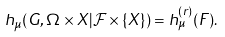Convert formula to latex. <formula><loc_0><loc_0><loc_500><loc_500>h _ { \mu } ( G , \Omega \times X | \mathcal { F } \times \{ X \} ) = h _ { \mu } ^ { ( r ) } ( F ) .</formula> 